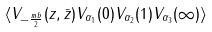Convert formula to latex. <formula><loc_0><loc_0><loc_500><loc_500>\langle V _ { - \frac { m b } { 2 } } ( z , \bar { z } ) V _ { \alpha _ { 1 } } ( 0 ) V _ { \alpha _ { 2 } } ( 1 ) V _ { \alpha _ { 3 } } ( \infty ) \rangle</formula> 